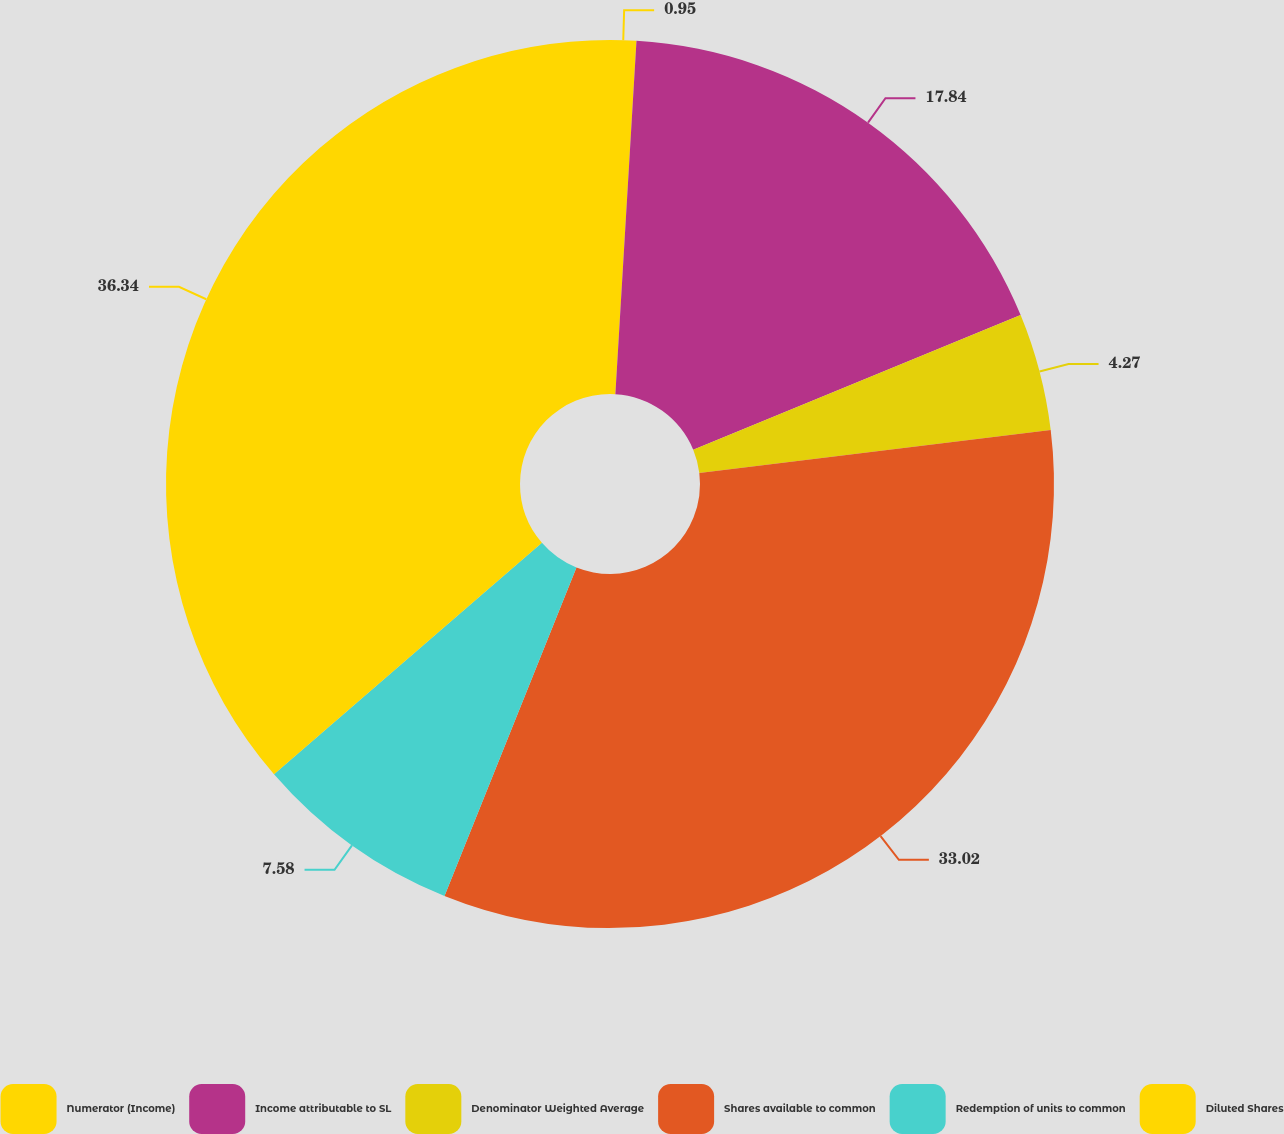Convert chart. <chart><loc_0><loc_0><loc_500><loc_500><pie_chart><fcel>Numerator (Income)<fcel>Income attributable to SL<fcel>Denominator Weighted Average<fcel>Shares available to common<fcel>Redemption of units to common<fcel>Diluted Shares<nl><fcel>0.95%<fcel>17.84%<fcel>4.27%<fcel>33.02%<fcel>7.58%<fcel>36.34%<nl></chart> 